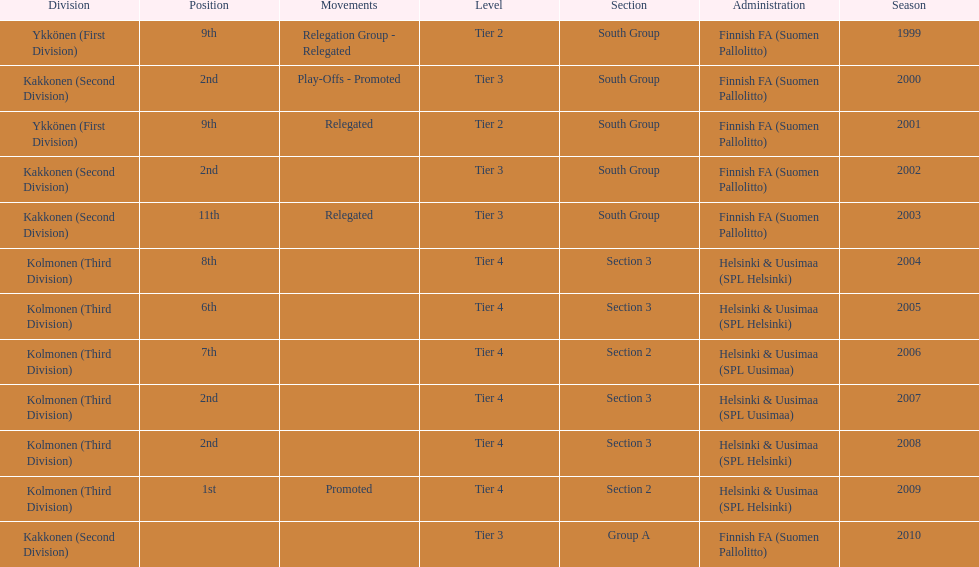I'm looking to parse the entire table for insights. Could you assist me with that? {'header': ['Division', 'Position', 'Movements', 'Level', 'Section', 'Administration', 'Season'], 'rows': [['Ykkönen (First Division)', '9th', 'Relegation Group - Relegated', 'Tier 2', 'South Group', 'Finnish FA (Suomen Pallolitto)', '1999'], ['Kakkonen (Second Division)', '2nd', 'Play-Offs - Promoted', 'Tier 3', 'South Group', 'Finnish FA (Suomen Pallolitto)', '2000'], ['Ykkönen (First Division)', '9th', 'Relegated', 'Tier 2', 'South Group', 'Finnish FA (Suomen Pallolitto)', '2001'], ['Kakkonen (Second Division)', '2nd', '', 'Tier 3', 'South Group', 'Finnish FA (Suomen Pallolitto)', '2002'], ['Kakkonen (Second Division)', '11th', 'Relegated', 'Tier 3', 'South Group', 'Finnish FA (Suomen Pallolitto)', '2003'], ['Kolmonen (Third Division)', '8th', '', 'Tier 4', 'Section 3', 'Helsinki & Uusimaa (SPL Helsinki)', '2004'], ['Kolmonen (Third Division)', '6th', '', 'Tier 4', 'Section 3', 'Helsinki & Uusimaa (SPL Helsinki)', '2005'], ['Kolmonen (Third Division)', '7th', '', 'Tier 4', 'Section 2', 'Helsinki & Uusimaa (SPL Uusimaa)', '2006'], ['Kolmonen (Third Division)', '2nd', '', 'Tier 4', 'Section 3', 'Helsinki & Uusimaa (SPL Uusimaa)', '2007'], ['Kolmonen (Third Division)', '2nd', '', 'Tier 4', 'Section 3', 'Helsinki & Uusimaa (SPL Helsinki)', '2008'], ['Kolmonen (Third Division)', '1st', 'Promoted', 'Tier 4', 'Section 2', 'Helsinki & Uusimaa (SPL Helsinki)', '2009'], ['Kakkonen (Second Division)', '', '', 'Tier 3', 'Group A', 'Finnish FA (Suomen Pallolitto)', '2010']]} How many tiers had more than one relegated movement? 1. 